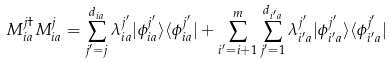<formula> <loc_0><loc_0><loc_500><loc_500>M ^ { j \dagger } _ { i a } M ^ { j } _ { i a } = \sum _ { j ^ { \prime } = j } ^ { d _ { i a } } { \lambda ^ { j ^ { \prime } } _ { i a } | \phi ^ { j ^ { \prime } } _ { i a } \rangle \langle \phi ^ { j ^ { \prime } } _ { i a } | } + \sum _ { i ^ { \prime } = i + 1 } ^ { m } \sum _ { j ^ { \prime } = 1 } ^ { d _ { i ^ { \prime } a } } { \lambda ^ { j ^ { \prime } } _ { i ^ { \prime } a } | \phi ^ { j ^ { \prime } } _ { i ^ { \prime } a } \rangle \langle \phi ^ { j ^ { \prime } } _ { i ^ { \prime } a } | }</formula> 